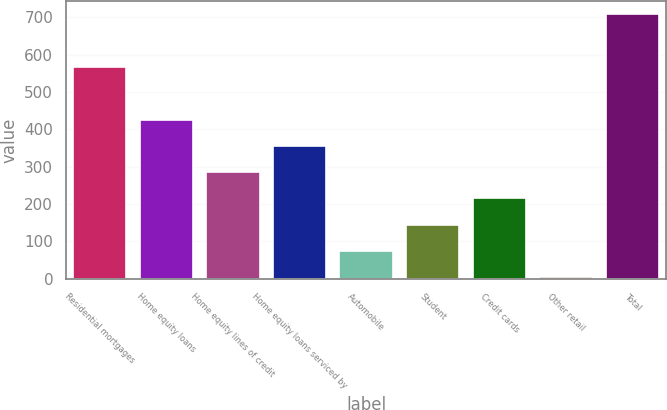Convert chart. <chart><loc_0><loc_0><loc_500><loc_500><bar_chart><fcel>Residential mortgages<fcel>Home equity loans<fcel>Home equity lines of credit<fcel>Home equity loans serviced by<fcel>Automobile<fcel>Student<fcel>Credit cards<fcel>Other retail<fcel>Total<nl><fcel>567.2<fcel>426.4<fcel>285.6<fcel>356<fcel>74.4<fcel>144.8<fcel>215.2<fcel>4<fcel>708<nl></chart> 